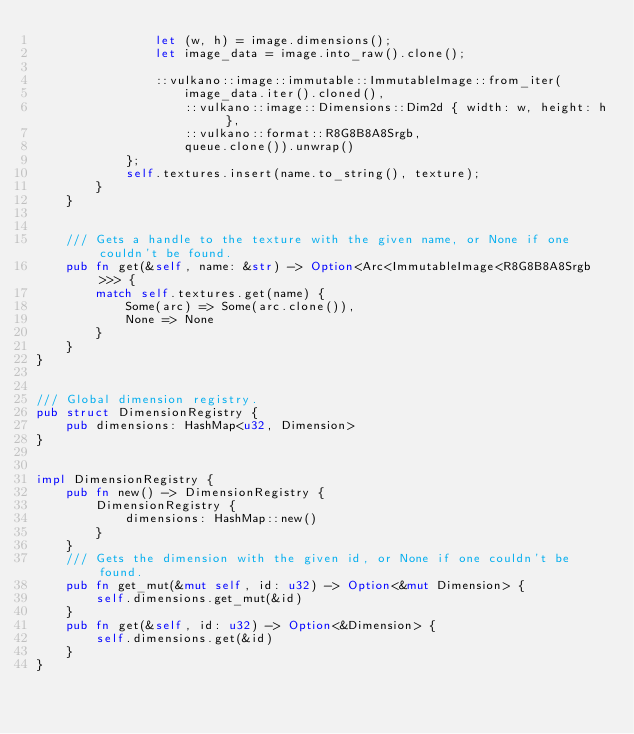Convert code to text. <code><loc_0><loc_0><loc_500><loc_500><_Rust_>                let (w, h) = image.dimensions();
                let image_data = image.into_raw().clone();

                ::vulkano::image::immutable::ImmutableImage::from_iter(
                    image_data.iter().cloned(),
                    ::vulkano::image::Dimensions::Dim2d { width: w, height: h },
                    ::vulkano::format::R8G8B8A8Srgb,
                    queue.clone()).unwrap()
            };
            self.textures.insert(name.to_string(), texture);
        }
    }


    /// Gets a handle to the texture with the given name, or None if one couldn't be found.
    pub fn get(&self, name: &str) -> Option<Arc<ImmutableImage<R8G8B8A8Srgb>>> {
        match self.textures.get(name) {
            Some(arc) => Some(arc.clone()),
            None => None
        }
    }
}


/// Global dimension registry.
pub struct DimensionRegistry {
    pub dimensions: HashMap<u32, Dimension>
}


impl DimensionRegistry {
    pub fn new() -> DimensionRegistry {
        DimensionRegistry {
            dimensions: HashMap::new()
        }
    }
    /// Gets the dimension with the given id, or None if one couldn't be found.
    pub fn get_mut(&mut self, id: u32) -> Option<&mut Dimension> {
        self.dimensions.get_mut(&id)
    }
    pub fn get(&self, id: u32) -> Option<&Dimension> {
        self.dimensions.get(&id)
    }
}</code> 